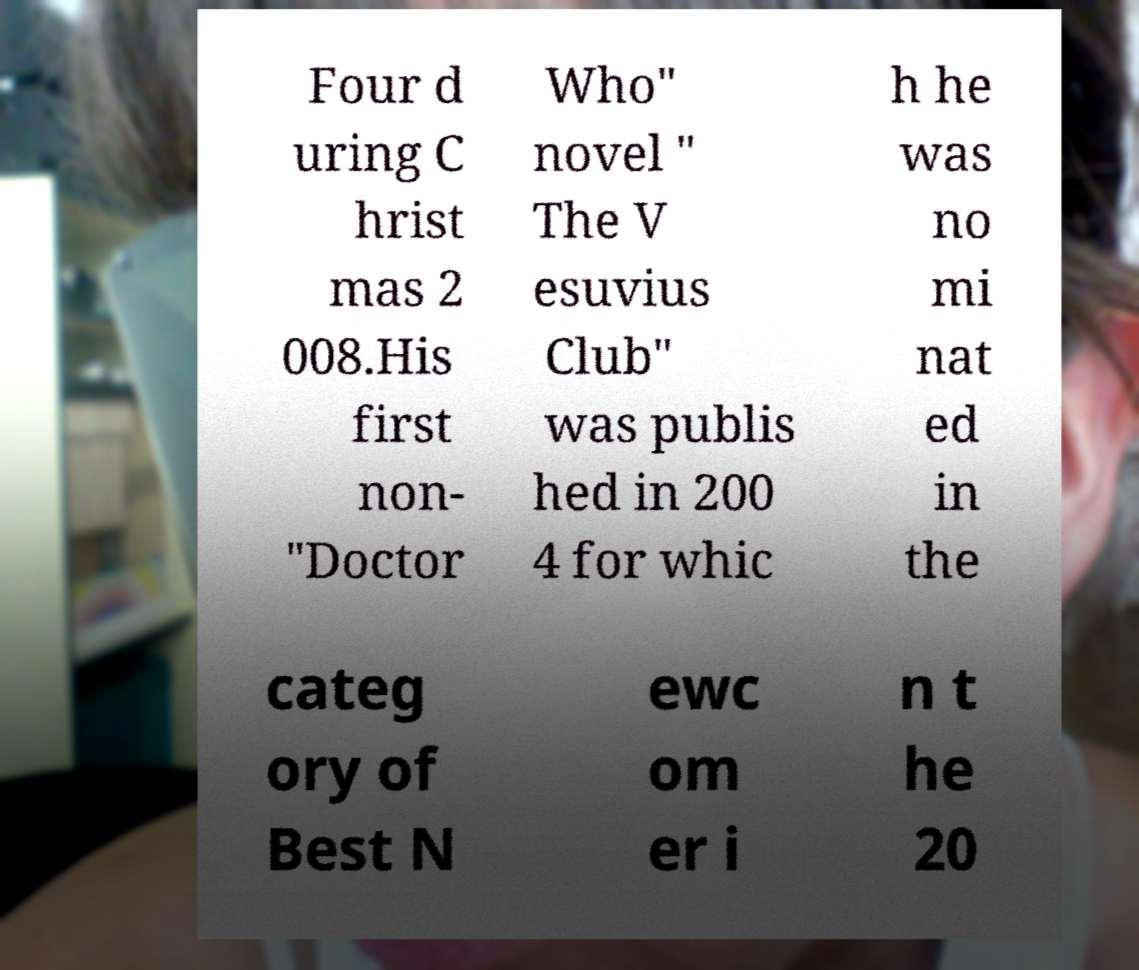Could you assist in decoding the text presented in this image and type it out clearly? Four d uring C hrist mas 2 008.His first non- "Doctor Who" novel " The V esuvius Club" was publis hed in 200 4 for whic h he was no mi nat ed in the categ ory of Best N ewc om er i n t he 20 